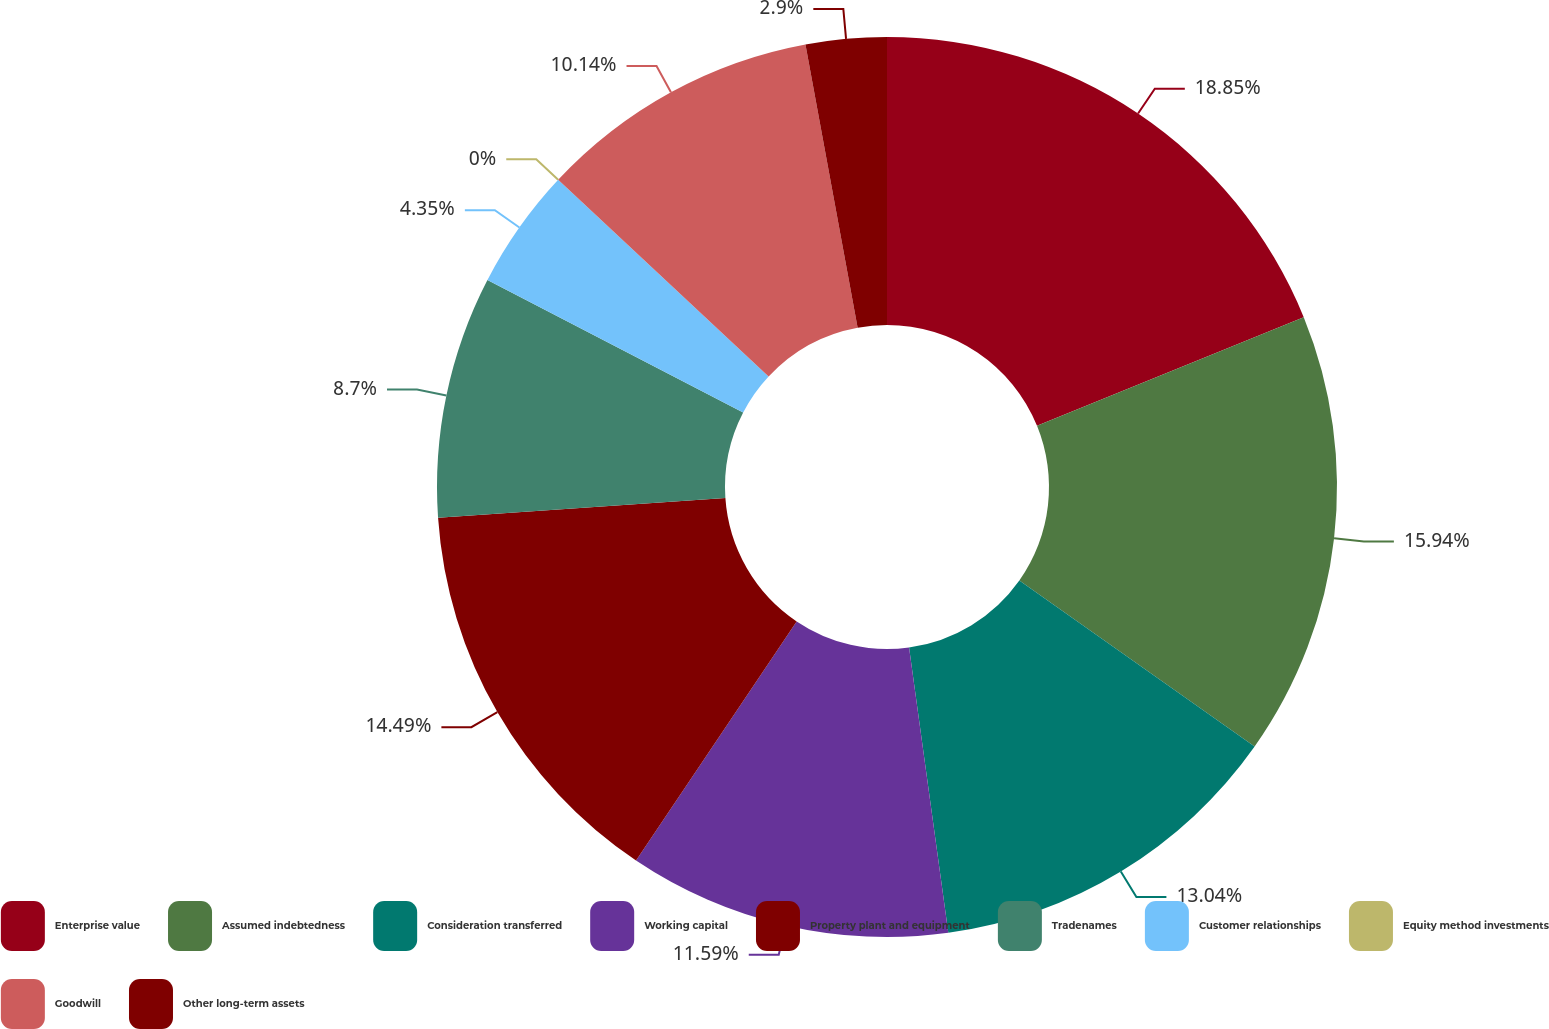Convert chart to OTSL. <chart><loc_0><loc_0><loc_500><loc_500><pie_chart><fcel>Enterprise value<fcel>Assumed indebtedness<fcel>Consideration transferred<fcel>Working capital<fcel>Property plant and equipment<fcel>Tradenames<fcel>Customer relationships<fcel>Equity method investments<fcel>Goodwill<fcel>Other long-term assets<nl><fcel>18.84%<fcel>15.94%<fcel>13.04%<fcel>11.59%<fcel>14.49%<fcel>8.7%<fcel>4.35%<fcel>0.0%<fcel>10.14%<fcel>2.9%<nl></chart> 